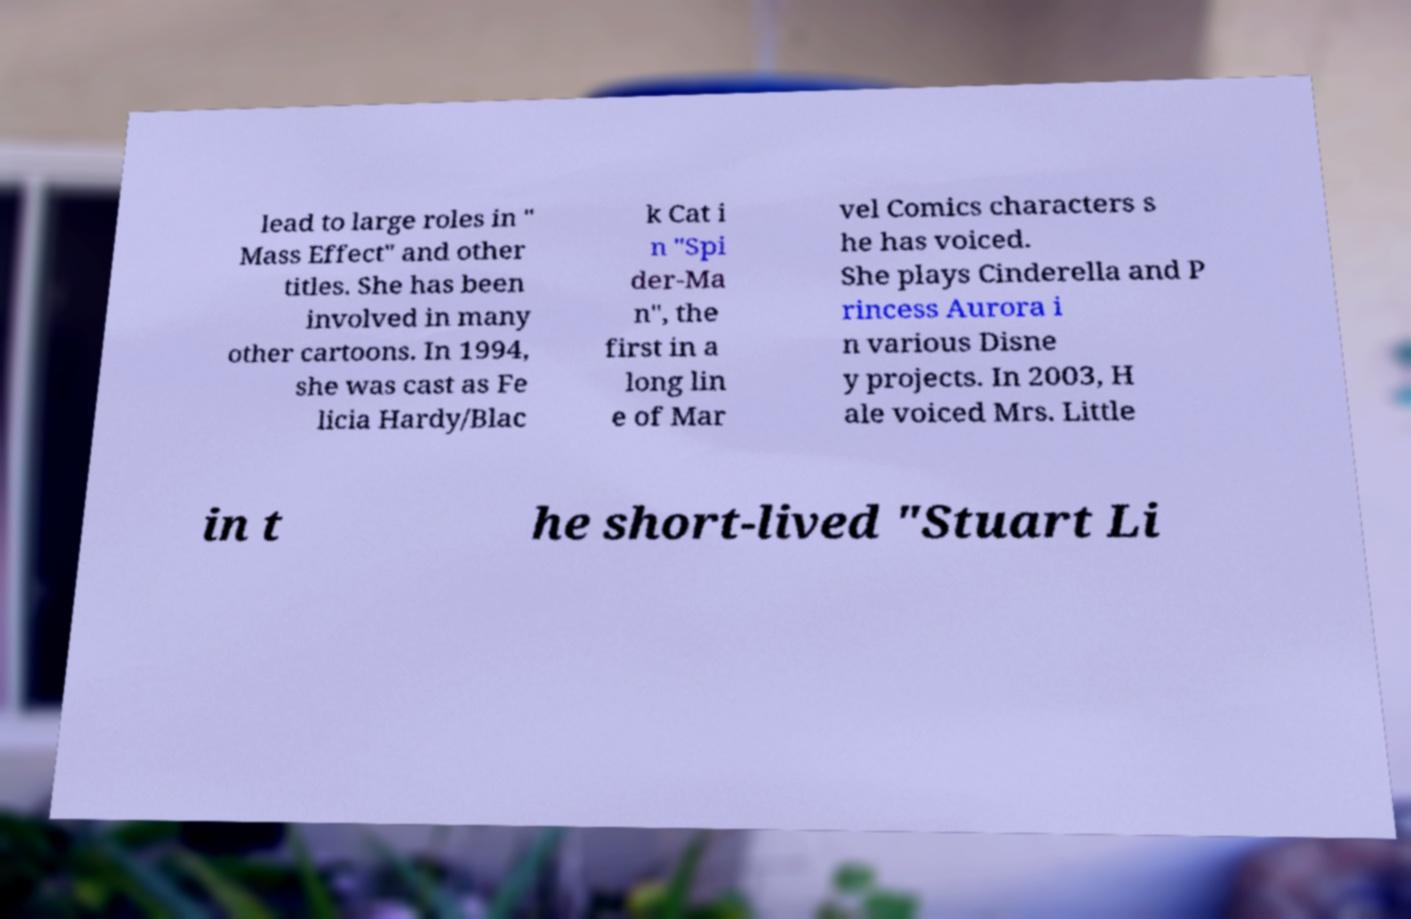Can you accurately transcribe the text from the provided image for me? lead to large roles in " Mass Effect" and other titles. She has been involved in many other cartoons. In 1994, she was cast as Fe licia Hardy/Blac k Cat i n "Spi der-Ma n", the first in a long lin e of Mar vel Comics characters s he has voiced. She plays Cinderella and P rincess Aurora i n various Disne y projects. In 2003, H ale voiced Mrs. Little in t he short-lived "Stuart Li 